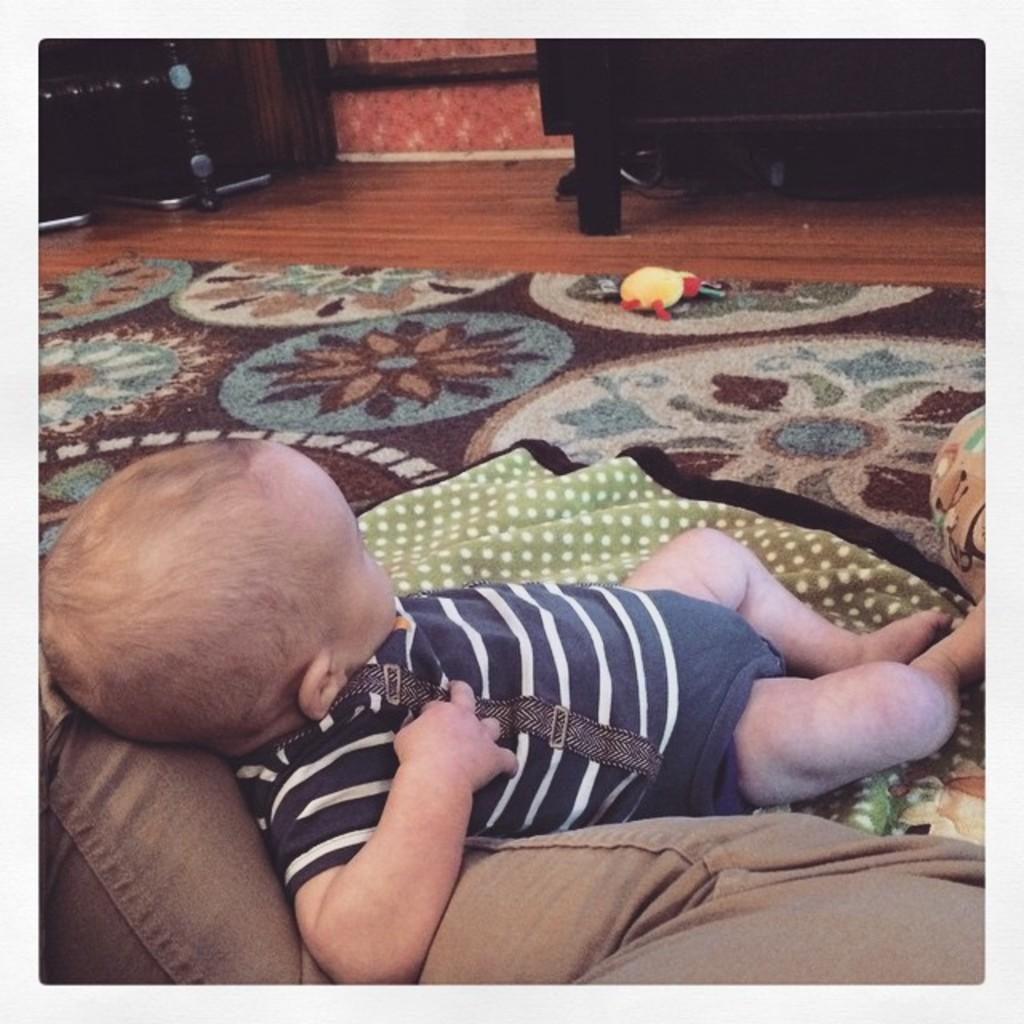What is the baby doing in the image? The baby is lying on the legs of a person in the image. What is on the floor beneath the baby? There is a carpet on the floor. What can be seen on the carpet? There is a toy on the carpet. What type of furniture is visible at the top of the image? There are cupboards at the top of the image. What word is the baby trying to say in the image? There is no indication in the image that the baby is trying to say a word. Can you see a cow in the image? No, there is no cow present in the image. 